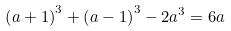<formula> <loc_0><loc_0><loc_500><loc_500>\left ( a + 1 \right ) ^ { 3 } + \left ( a - 1 \right ) ^ { 3 } - 2 a ^ { 3 } = 6 a</formula> 